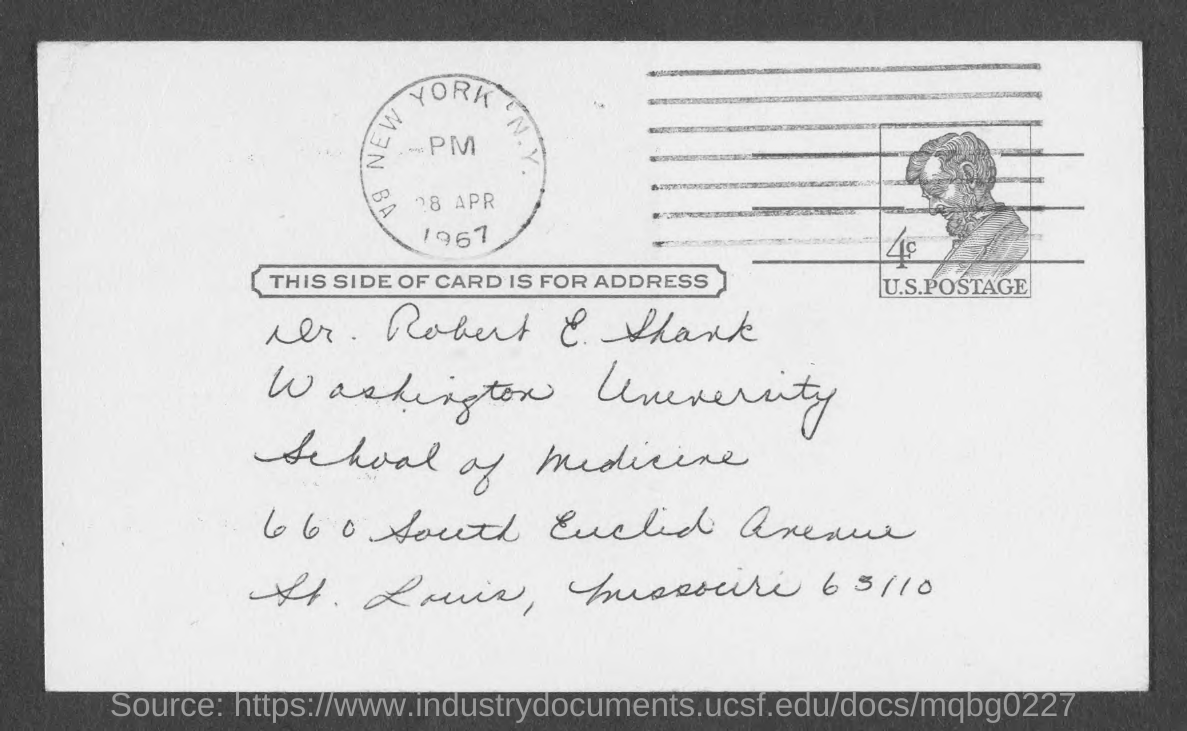Which University is mentioned in the address given?
Make the answer very short. Washington University. What is the date mentioned in the postage stamp?
Offer a terse response. 28 APR 1967. 